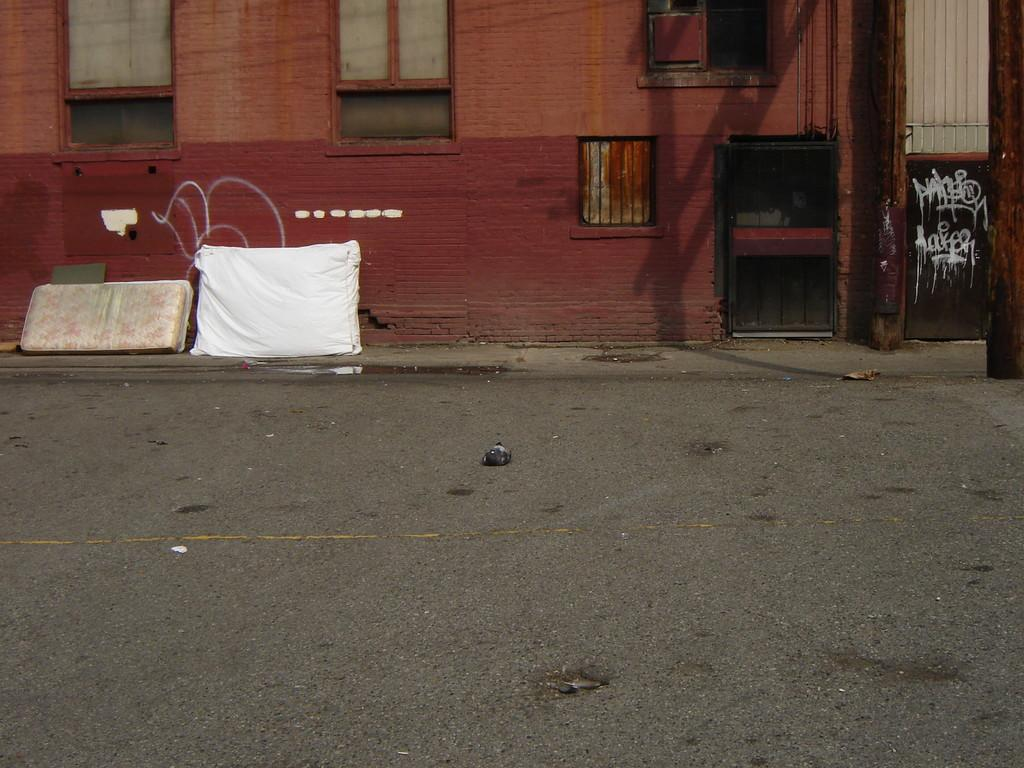What is the color of the building in the image? The building in the image has a red and brown color. What feature of the building is mentioned in the facts? The building has windows. What is the color of the gate in the image? The gate in the image is black. What color objects are on the road in the image? There are white and cream color objects on the road. Can you see any goldfish swimming in the image? There are no goldfish present in the image. Is the whip used for cracking in the image? There is no whip present in the image. 